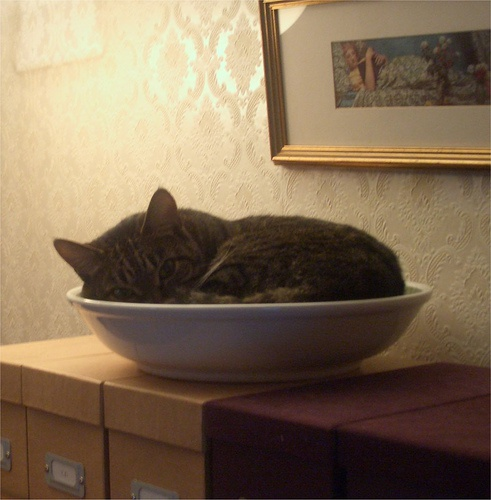Describe the objects in this image and their specific colors. I can see cat in beige, black, maroon, and tan tones and bowl in beige, black, gray, and maroon tones in this image. 